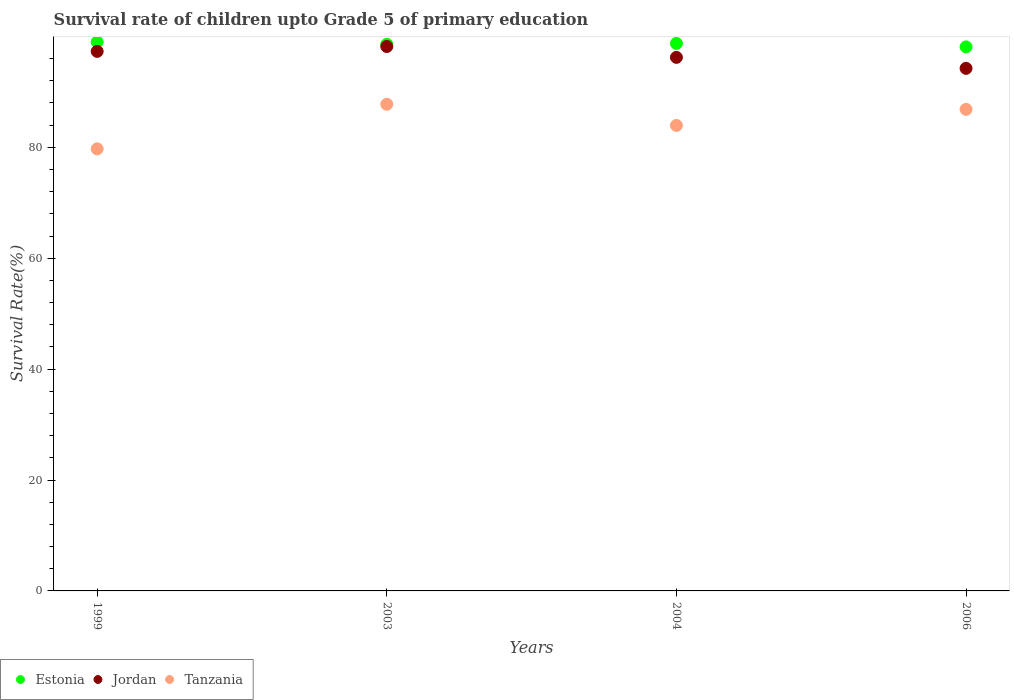How many different coloured dotlines are there?
Provide a succinct answer. 3. What is the survival rate of children in Estonia in 2003?
Provide a succinct answer. 98.57. Across all years, what is the maximum survival rate of children in Tanzania?
Offer a terse response. 87.77. Across all years, what is the minimum survival rate of children in Estonia?
Give a very brief answer. 98.12. In which year was the survival rate of children in Jordan maximum?
Provide a short and direct response. 2003. What is the total survival rate of children in Jordan in the graph?
Your answer should be compact. 385.96. What is the difference between the survival rate of children in Jordan in 1999 and that in 2006?
Offer a very short reply. 3.06. What is the difference between the survival rate of children in Estonia in 2004 and the survival rate of children in Tanzania in 2003?
Keep it short and to the point. 10.97. What is the average survival rate of children in Tanzania per year?
Your answer should be very brief. 84.58. In the year 2004, what is the difference between the survival rate of children in Tanzania and survival rate of children in Estonia?
Offer a terse response. -14.79. In how many years, is the survival rate of children in Jordan greater than 28 %?
Provide a succinct answer. 4. What is the ratio of the survival rate of children in Estonia in 1999 to that in 2003?
Offer a very short reply. 1. Is the survival rate of children in Tanzania in 1999 less than that in 2004?
Ensure brevity in your answer.  Yes. What is the difference between the highest and the second highest survival rate of children in Tanzania?
Provide a succinct answer. 0.91. What is the difference between the highest and the lowest survival rate of children in Estonia?
Provide a succinct answer. 0.89. In how many years, is the survival rate of children in Jordan greater than the average survival rate of children in Jordan taken over all years?
Keep it short and to the point. 2. Does the survival rate of children in Jordan monotonically increase over the years?
Offer a terse response. No. What is the difference between two consecutive major ticks on the Y-axis?
Make the answer very short. 20. Are the values on the major ticks of Y-axis written in scientific E-notation?
Make the answer very short. No. Does the graph contain grids?
Provide a short and direct response. No. How are the legend labels stacked?
Offer a terse response. Horizontal. What is the title of the graph?
Your answer should be compact. Survival rate of children upto Grade 5 of primary education. What is the label or title of the X-axis?
Make the answer very short. Years. What is the label or title of the Y-axis?
Provide a short and direct response. Survival Rate(%). What is the Survival Rate(%) of Estonia in 1999?
Give a very brief answer. 99.01. What is the Survival Rate(%) in Jordan in 1999?
Your response must be concise. 97.31. What is the Survival Rate(%) of Tanzania in 1999?
Keep it short and to the point. 79.73. What is the Survival Rate(%) in Estonia in 2003?
Keep it short and to the point. 98.57. What is the Survival Rate(%) of Jordan in 2003?
Ensure brevity in your answer.  98.18. What is the Survival Rate(%) of Tanzania in 2003?
Provide a succinct answer. 87.77. What is the Survival Rate(%) of Estonia in 2004?
Offer a very short reply. 98.74. What is the Survival Rate(%) in Jordan in 2004?
Your answer should be compact. 96.23. What is the Survival Rate(%) in Tanzania in 2004?
Provide a succinct answer. 83.95. What is the Survival Rate(%) in Estonia in 2006?
Offer a very short reply. 98.12. What is the Survival Rate(%) of Jordan in 2006?
Your answer should be compact. 94.25. What is the Survival Rate(%) in Tanzania in 2006?
Give a very brief answer. 86.86. Across all years, what is the maximum Survival Rate(%) in Estonia?
Your answer should be very brief. 99.01. Across all years, what is the maximum Survival Rate(%) of Jordan?
Your answer should be compact. 98.18. Across all years, what is the maximum Survival Rate(%) of Tanzania?
Your answer should be very brief. 87.77. Across all years, what is the minimum Survival Rate(%) in Estonia?
Your answer should be compact. 98.12. Across all years, what is the minimum Survival Rate(%) of Jordan?
Offer a very short reply. 94.25. Across all years, what is the minimum Survival Rate(%) in Tanzania?
Ensure brevity in your answer.  79.73. What is the total Survival Rate(%) in Estonia in the graph?
Make the answer very short. 394.45. What is the total Survival Rate(%) in Jordan in the graph?
Your response must be concise. 385.96. What is the total Survival Rate(%) in Tanzania in the graph?
Your response must be concise. 338.31. What is the difference between the Survival Rate(%) in Estonia in 1999 and that in 2003?
Provide a succinct answer. 0.44. What is the difference between the Survival Rate(%) in Jordan in 1999 and that in 2003?
Make the answer very short. -0.88. What is the difference between the Survival Rate(%) in Tanzania in 1999 and that in 2003?
Your answer should be very brief. -8.04. What is the difference between the Survival Rate(%) of Estonia in 1999 and that in 2004?
Your answer should be compact. 0.27. What is the difference between the Survival Rate(%) in Jordan in 1999 and that in 2004?
Offer a terse response. 1.08. What is the difference between the Survival Rate(%) of Tanzania in 1999 and that in 2004?
Give a very brief answer. -4.23. What is the difference between the Survival Rate(%) of Estonia in 1999 and that in 2006?
Your response must be concise. 0.89. What is the difference between the Survival Rate(%) of Jordan in 1999 and that in 2006?
Your response must be concise. 3.06. What is the difference between the Survival Rate(%) in Tanzania in 1999 and that in 2006?
Ensure brevity in your answer.  -7.13. What is the difference between the Survival Rate(%) of Estonia in 2003 and that in 2004?
Keep it short and to the point. -0.17. What is the difference between the Survival Rate(%) of Jordan in 2003 and that in 2004?
Your answer should be very brief. 1.96. What is the difference between the Survival Rate(%) of Tanzania in 2003 and that in 2004?
Make the answer very short. 3.81. What is the difference between the Survival Rate(%) of Estonia in 2003 and that in 2006?
Provide a short and direct response. 0.46. What is the difference between the Survival Rate(%) of Jordan in 2003 and that in 2006?
Your answer should be very brief. 3.94. What is the difference between the Survival Rate(%) of Tanzania in 2003 and that in 2006?
Provide a short and direct response. 0.91. What is the difference between the Survival Rate(%) of Estonia in 2004 and that in 2006?
Offer a very short reply. 0.62. What is the difference between the Survival Rate(%) in Jordan in 2004 and that in 2006?
Your response must be concise. 1.98. What is the difference between the Survival Rate(%) in Tanzania in 2004 and that in 2006?
Give a very brief answer. -2.9. What is the difference between the Survival Rate(%) of Estonia in 1999 and the Survival Rate(%) of Jordan in 2003?
Your answer should be very brief. 0.83. What is the difference between the Survival Rate(%) of Estonia in 1999 and the Survival Rate(%) of Tanzania in 2003?
Your answer should be compact. 11.24. What is the difference between the Survival Rate(%) in Jordan in 1999 and the Survival Rate(%) in Tanzania in 2003?
Your answer should be compact. 9.54. What is the difference between the Survival Rate(%) in Estonia in 1999 and the Survival Rate(%) in Jordan in 2004?
Keep it short and to the point. 2.79. What is the difference between the Survival Rate(%) in Estonia in 1999 and the Survival Rate(%) in Tanzania in 2004?
Your answer should be very brief. 15.06. What is the difference between the Survival Rate(%) of Jordan in 1999 and the Survival Rate(%) of Tanzania in 2004?
Your answer should be very brief. 13.35. What is the difference between the Survival Rate(%) of Estonia in 1999 and the Survival Rate(%) of Jordan in 2006?
Ensure brevity in your answer.  4.77. What is the difference between the Survival Rate(%) in Estonia in 1999 and the Survival Rate(%) in Tanzania in 2006?
Keep it short and to the point. 12.16. What is the difference between the Survival Rate(%) in Jordan in 1999 and the Survival Rate(%) in Tanzania in 2006?
Provide a short and direct response. 10.45. What is the difference between the Survival Rate(%) of Estonia in 2003 and the Survival Rate(%) of Jordan in 2004?
Provide a short and direct response. 2.35. What is the difference between the Survival Rate(%) of Estonia in 2003 and the Survival Rate(%) of Tanzania in 2004?
Provide a succinct answer. 14.62. What is the difference between the Survival Rate(%) of Jordan in 2003 and the Survival Rate(%) of Tanzania in 2004?
Provide a succinct answer. 14.23. What is the difference between the Survival Rate(%) of Estonia in 2003 and the Survival Rate(%) of Jordan in 2006?
Offer a very short reply. 4.33. What is the difference between the Survival Rate(%) of Estonia in 2003 and the Survival Rate(%) of Tanzania in 2006?
Your answer should be very brief. 11.72. What is the difference between the Survival Rate(%) of Jordan in 2003 and the Survival Rate(%) of Tanzania in 2006?
Make the answer very short. 11.33. What is the difference between the Survival Rate(%) in Estonia in 2004 and the Survival Rate(%) in Jordan in 2006?
Ensure brevity in your answer.  4.49. What is the difference between the Survival Rate(%) of Estonia in 2004 and the Survival Rate(%) of Tanzania in 2006?
Your response must be concise. 11.88. What is the difference between the Survival Rate(%) of Jordan in 2004 and the Survival Rate(%) of Tanzania in 2006?
Your answer should be compact. 9.37. What is the average Survival Rate(%) in Estonia per year?
Keep it short and to the point. 98.61. What is the average Survival Rate(%) of Jordan per year?
Offer a very short reply. 96.49. What is the average Survival Rate(%) of Tanzania per year?
Keep it short and to the point. 84.58. In the year 1999, what is the difference between the Survival Rate(%) of Estonia and Survival Rate(%) of Jordan?
Your answer should be very brief. 1.71. In the year 1999, what is the difference between the Survival Rate(%) of Estonia and Survival Rate(%) of Tanzania?
Offer a terse response. 19.28. In the year 1999, what is the difference between the Survival Rate(%) of Jordan and Survival Rate(%) of Tanzania?
Your response must be concise. 17.58. In the year 2003, what is the difference between the Survival Rate(%) of Estonia and Survival Rate(%) of Jordan?
Give a very brief answer. 0.39. In the year 2003, what is the difference between the Survival Rate(%) in Estonia and Survival Rate(%) in Tanzania?
Ensure brevity in your answer.  10.81. In the year 2003, what is the difference between the Survival Rate(%) of Jordan and Survival Rate(%) of Tanzania?
Your answer should be compact. 10.42. In the year 2004, what is the difference between the Survival Rate(%) in Estonia and Survival Rate(%) in Jordan?
Your answer should be compact. 2.51. In the year 2004, what is the difference between the Survival Rate(%) of Estonia and Survival Rate(%) of Tanzania?
Keep it short and to the point. 14.79. In the year 2004, what is the difference between the Survival Rate(%) in Jordan and Survival Rate(%) in Tanzania?
Your answer should be very brief. 12.27. In the year 2006, what is the difference between the Survival Rate(%) of Estonia and Survival Rate(%) of Jordan?
Your response must be concise. 3.87. In the year 2006, what is the difference between the Survival Rate(%) in Estonia and Survival Rate(%) in Tanzania?
Keep it short and to the point. 11.26. In the year 2006, what is the difference between the Survival Rate(%) in Jordan and Survival Rate(%) in Tanzania?
Make the answer very short. 7.39. What is the ratio of the Survival Rate(%) of Jordan in 1999 to that in 2003?
Ensure brevity in your answer.  0.99. What is the ratio of the Survival Rate(%) in Tanzania in 1999 to that in 2003?
Make the answer very short. 0.91. What is the ratio of the Survival Rate(%) of Estonia in 1999 to that in 2004?
Provide a short and direct response. 1. What is the ratio of the Survival Rate(%) in Jordan in 1999 to that in 2004?
Ensure brevity in your answer.  1.01. What is the ratio of the Survival Rate(%) of Tanzania in 1999 to that in 2004?
Make the answer very short. 0.95. What is the ratio of the Survival Rate(%) of Estonia in 1999 to that in 2006?
Your answer should be compact. 1.01. What is the ratio of the Survival Rate(%) in Jordan in 1999 to that in 2006?
Keep it short and to the point. 1.03. What is the ratio of the Survival Rate(%) in Tanzania in 1999 to that in 2006?
Provide a short and direct response. 0.92. What is the ratio of the Survival Rate(%) of Jordan in 2003 to that in 2004?
Provide a short and direct response. 1.02. What is the ratio of the Survival Rate(%) of Tanzania in 2003 to that in 2004?
Ensure brevity in your answer.  1.05. What is the ratio of the Survival Rate(%) of Jordan in 2003 to that in 2006?
Make the answer very short. 1.04. What is the ratio of the Survival Rate(%) of Tanzania in 2003 to that in 2006?
Provide a succinct answer. 1.01. What is the ratio of the Survival Rate(%) in Estonia in 2004 to that in 2006?
Ensure brevity in your answer.  1.01. What is the ratio of the Survival Rate(%) of Jordan in 2004 to that in 2006?
Give a very brief answer. 1.02. What is the ratio of the Survival Rate(%) of Tanzania in 2004 to that in 2006?
Ensure brevity in your answer.  0.97. What is the difference between the highest and the second highest Survival Rate(%) in Estonia?
Offer a terse response. 0.27. What is the difference between the highest and the second highest Survival Rate(%) of Jordan?
Provide a short and direct response. 0.88. What is the difference between the highest and the second highest Survival Rate(%) of Tanzania?
Offer a very short reply. 0.91. What is the difference between the highest and the lowest Survival Rate(%) of Estonia?
Your response must be concise. 0.89. What is the difference between the highest and the lowest Survival Rate(%) in Jordan?
Provide a short and direct response. 3.94. What is the difference between the highest and the lowest Survival Rate(%) of Tanzania?
Provide a succinct answer. 8.04. 